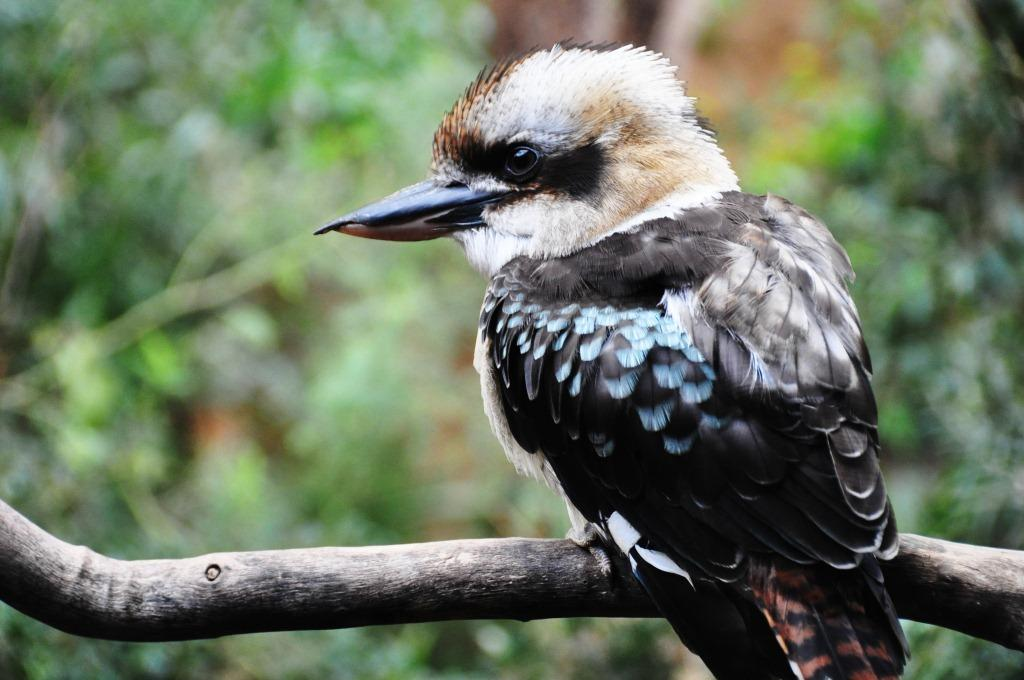What type of animal is in the image? There is a bird in the image. Can you describe the bird's color? The bird is white and black in color. Where is the bird located in the image? The bird is sitting on a stem. What can be seen in the background of the image? There are trees and plants in the background of the image. How is the background of the image depicted? The background is blurred. Can you see a cat flying a kite in the background of the image? There is no cat or kite present in the image; it features a bird sitting on a stem with a blurred background of trees and plants. 